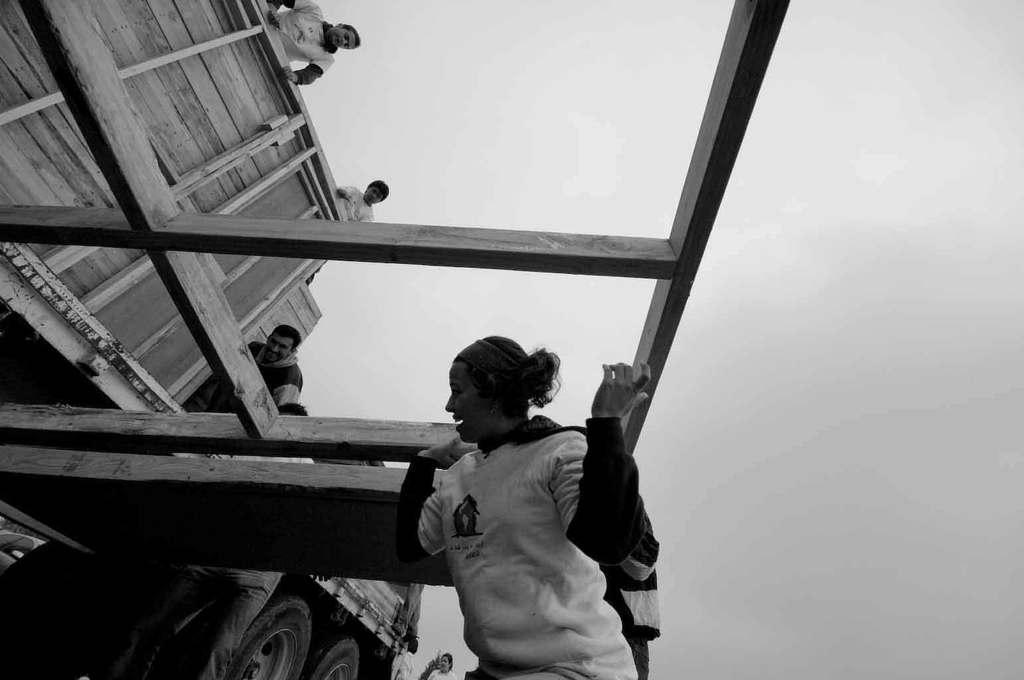What is the person holding in the image? The person is holding a wooden object in the image. What are the people on the vehicle doing? The people are standing on a vehicle in the image. What can be seen in the background of the image? The sky is visible in the background of the image. What type of flower is growing on the vehicle in the image? There is no flower present on the vehicle in the image. What type of badge is the person wearing while holding the wooden object? There is no badge visible on the person holding the wooden object in the image. 